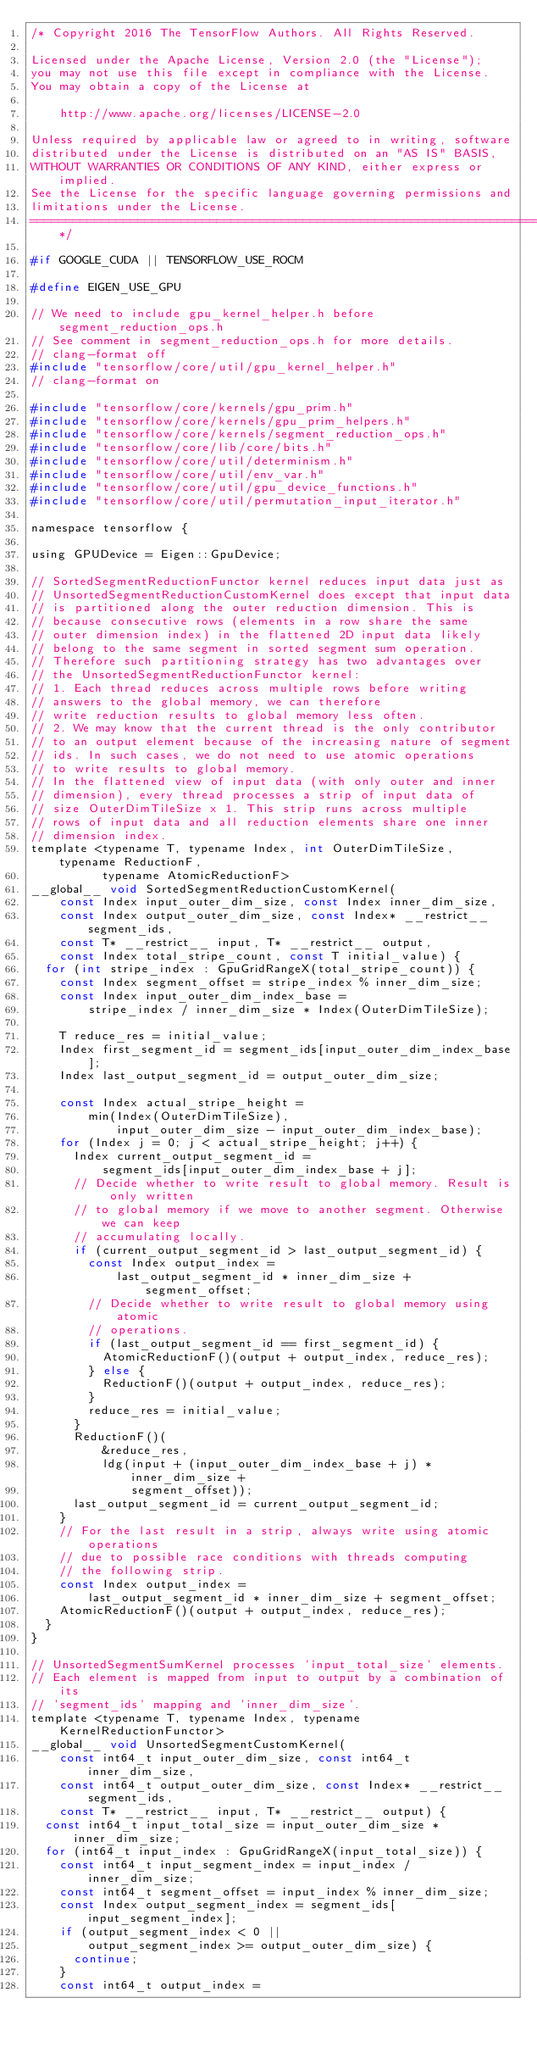<code> <loc_0><loc_0><loc_500><loc_500><_C_>/* Copyright 2016 The TensorFlow Authors. All Rights Reserved.

Licensed under the Apache License, Version 2.0 (the "License");
you may not use this file except in compliance with the License.
You may obtain a copy of the License at

    http://www.apache.org/licenses/LICENSE-2.0

Unless required by applicable law or agreed to in writing, software
distributed under the License is distributed on an "AS IS" BASIS,
WITHOUT WARRANTIES OR CONDITIONS OF ANY KIND, either express or implied.
See the License for the specific language governing permissions and
limitations under the License.
==============================================================================*/

#if GOOGLE_CUDA || TENSORFLOW_USE_ROCM

#define EIGEN_USE_GPU

// We need to include gpu_kernel_helper.h before segment_reduction_ops.h
// See comment in segment_reduction_ops.h for more details.
// clang-format off
#include "tensorflow/core/util/gpu_kernel_helper.h"
// clang-format on

#include "tensorflow/core/kernels/gpu_prim.h"
#include "tensorflow/core/kernels/gpu_prim_helpers.h"
#include "tensorflow/core/kernels/segment_reduction_ops.h"
#include "tensorflow/core/lib/core/bits.h"
#include "tensorflow/core/util/determinism.h"
#include "tensorflow/core/util/env_var.h"
#include "tensorflow/core/util/gpu_device_functions.h"
#include "tensorflow/core/util/permutation_input_iterator.h"

namespace tensorflow {

using GPUDevice = Eigen::GpuDevice;

// SortedSegmentReductionFunctor kernel reduces input data just as
// UnsortedSegmentReductionCustomKernel does except that input data
// is partitioned along the outer reduction dimension. This is
// because consecutive rows (elements in a row share the same
// outer dimension index) in the flattened 2D input data likely
// belong to the same segment in sorted segment sum operation.
// Therefore such partitioning strategy has two advantages over
// the UnsortedSegmentReductionFunctor kernel:
// 1. Each thread reduces across multiple rows before writing
// answers to the global memory, we can therefore
// write reduction results to global memory less often.
// 2. We may know that the current thread is the only contributor
// to an output element because of the increasing nature of segment
// ids. In such cases, we do not need to use atomic operations
// to write results to global memory.
// In the flattened view of input data (with only outer and inner
// dimension), every thread processes a strip of input data of
// size OuterDimTileSize x 1. This strip runs across multiple
// rows of input data and all reduction elements share one inner
// dimension index.
template <typename T, typename Index, int OuterDimTileSize, typename ReductionF,
          typename AtomicReductionF>
__global__ void SortedSegmentReductionCustomKernel(
    const Index input_outer_dim_size, const Index inner_dim_size,
    const Index output_outer_dim_size, const Index* __restrict__ segment_ids,
    const T* __restrict__ input, T* __restrict__ output,
    const Index total_stripe_count, const T initial_value) {
  for (int stripe_index : GpuGridRangeX(total_stripe_count)) {
    const Index segment_offset = stripe_index % inner_dim_size;
    const Index input_outer_dim_index_base =
        stripe_index / inner_dim_size * Index(OuterDimTileSize);

    T reduce_res = initial_value;
    Index first_segment_id = segment_ids[input_outer_dim_index_base];
    Index last_output_segment_id = output_outer_dim_size;

    const Index actual_stripe_height =
        min(Index(OuterDimTileSize),
            input_outer_dim_size - input_outer_dim_index_base);
    for (Index j = 0; j < actual_stripe_height; j++) {
      Index current_output_segment_id =
          segment_ids[input_outer_dim_index_base + j];
      // Decide whether to write result to global memory. Result is only written
      // to global memory if we move to another segment. Otherwise we can keep
      // accumulating locally.
      if (current_output_segment_id > last_output_segment_id) {
        const Index output_index =
            last_output_segment_id * inner_dim_size + segment_offset;
        // Decide whether to write result to global memory using atomic
        // operations.
        if (last_output_segment_id == first_segment_id) {
          AtomicReductionF()(output + output_index, reduce_res);
        } else {
          ReductionF()(output + output_index, reduce_res);
        }
        reduce_res = initial_value;
      }
      ReductionF()(
          &reduce_res,
          ldg(input + (input_outer_dim_index_base + j) * inner_dim_size +
              segment_offset));
      last_output_segment_id = current_output_segment_id;
    }
    // For the last result in a strip, always write using atomic operations
    // due to possible race conditions with threads computing
    // the following strip.
    const Index output_index =
        last_output_segment_id * inner_dim_size + segment_offset;
    AtomicReductionF()(output + output_index, reduce_res);
  }
}

// UnsortedSegmentSumKernel processes 'input_total_size' elements.
// Each element is mapped from input to output by a combination of its
// 'segment_ids' mapping and 'inner_dim_size'.
template <typename T, typename Index, typename KernelReductionFunctor>
__global__ void UnsortedSegmentCustomKernel(
    const int64_t input_outer_dim_size, const int64_t inner_dim_size,
    const int64_t output_outer_dim_size, const Index* __restrict__ segment_ids,
    const T* __restrict__ input, T* __restrict__ output) {
  const int64_t input_total_size = input_outer_dim_size * inner_dim_size;
  for (int64_t input_index : GpuGridRangeX(input_total_size)) {
    const int64_t input_segment_index = input_index / inner_dim_size;
    const int64_t segment_offset = input_index % inner_dim_size;
    const Index output_segment_index = segment_ids[input_segment_index];
    if (output_segment_index < 0 ||
        output_segment_index >= output_outer_dim_size) {
      continue;
    }
    const int64_t output_index =</code> 